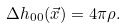<formula> <loc_0><loc_0><loc_500><loc_500>\Delta h _ { 0 0 } ( \vec { x } ) = 4 \pi \rho .</formula> 